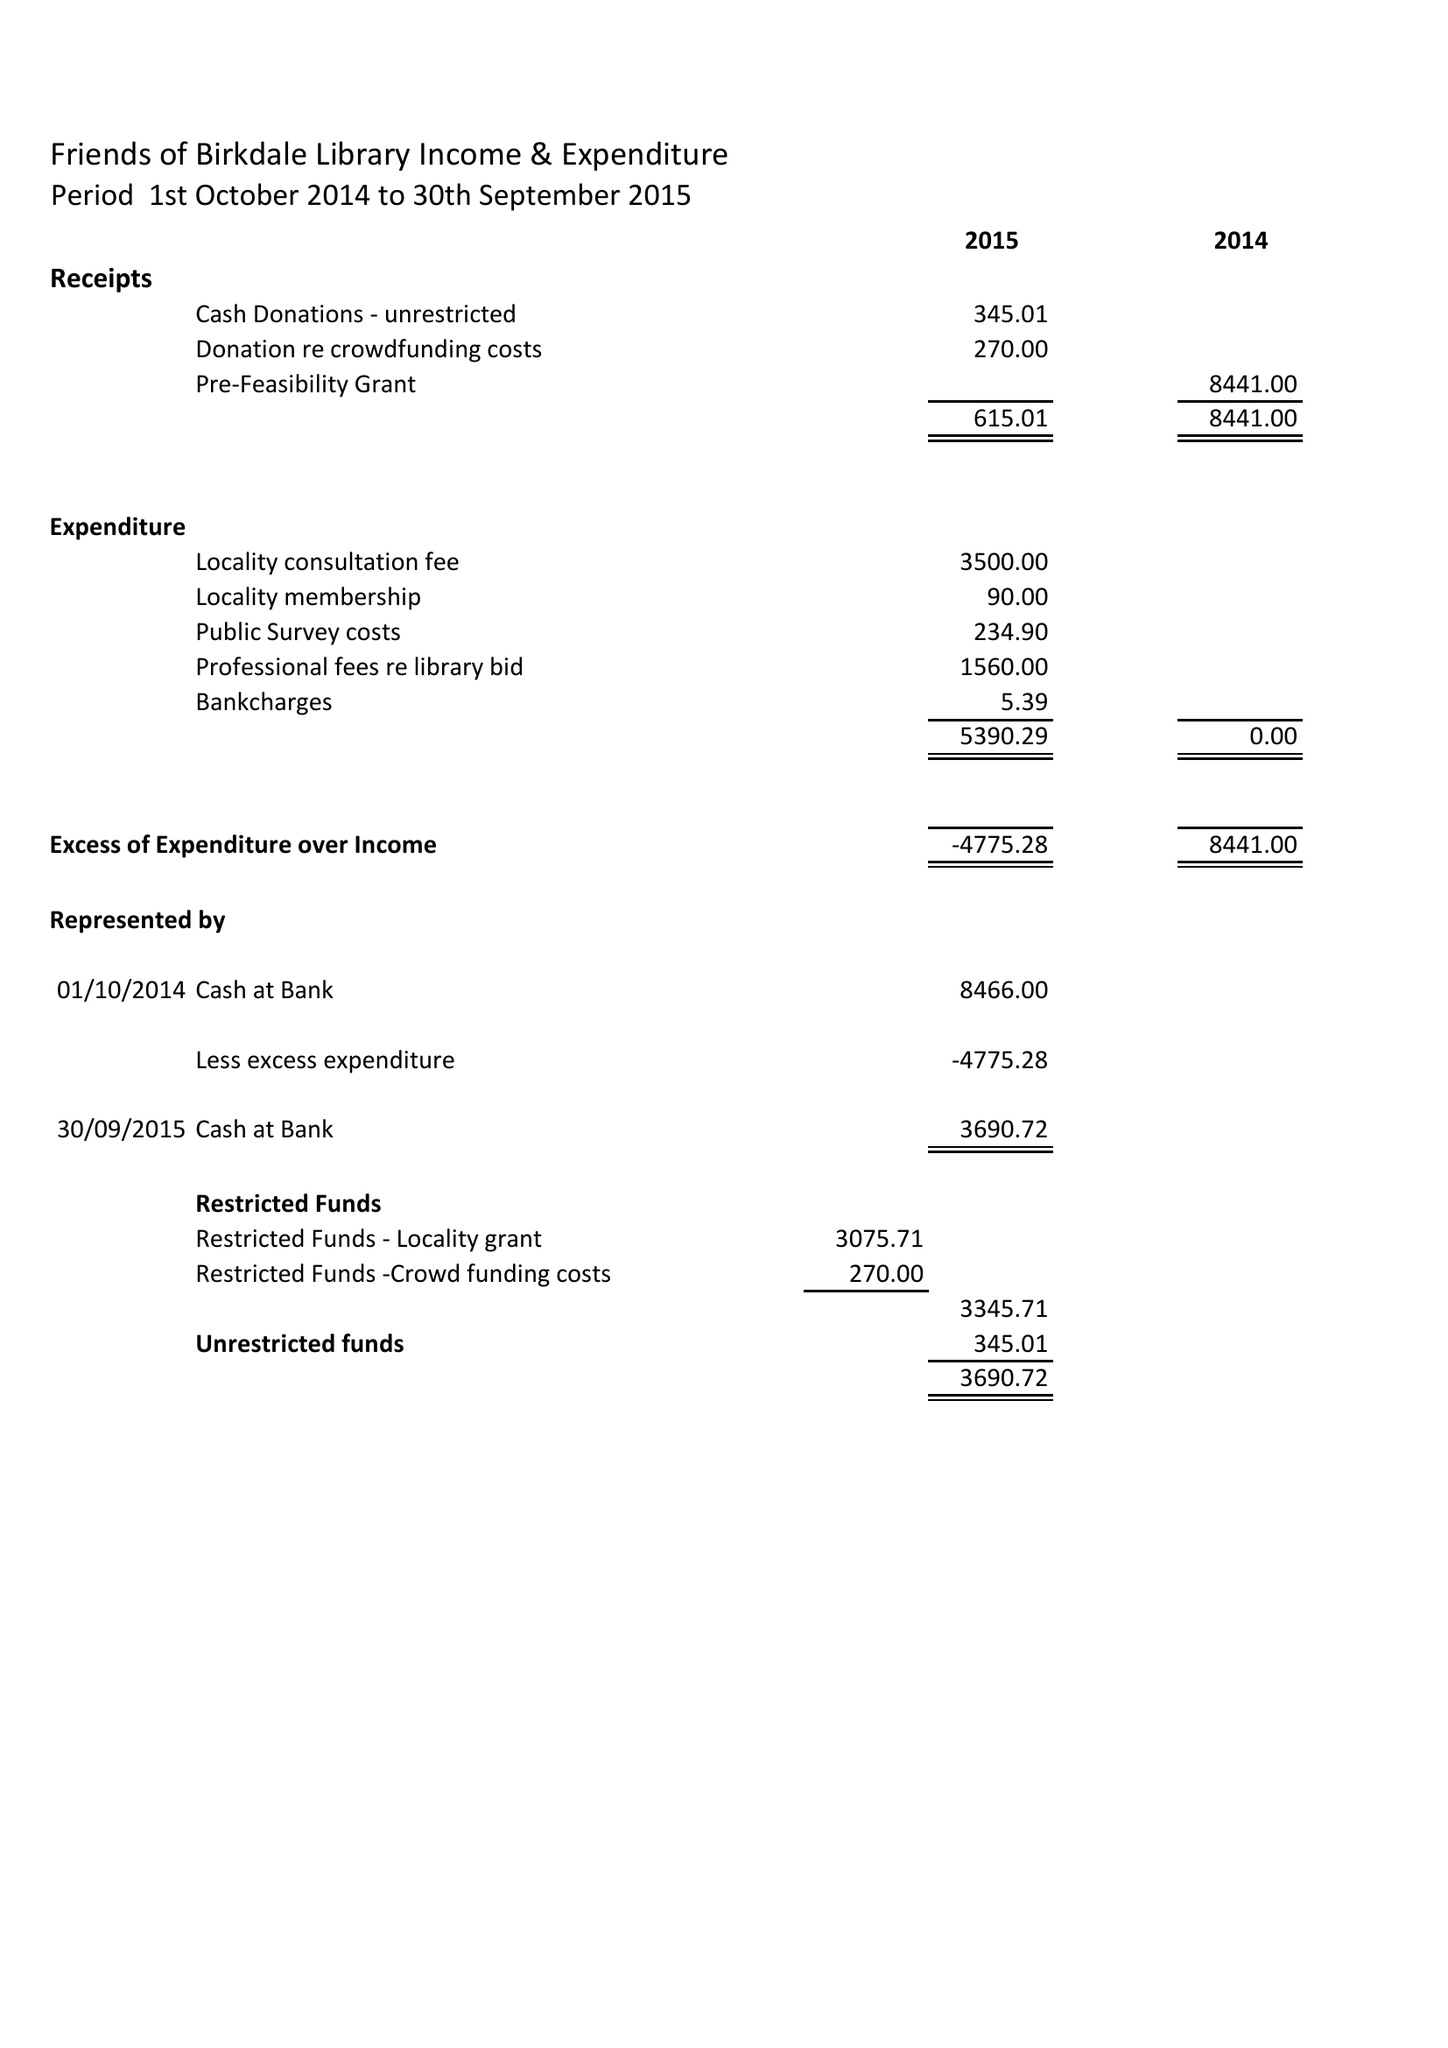What is the value for the report_date?
Answer the question using a single word or phrase. 2015-09-30 